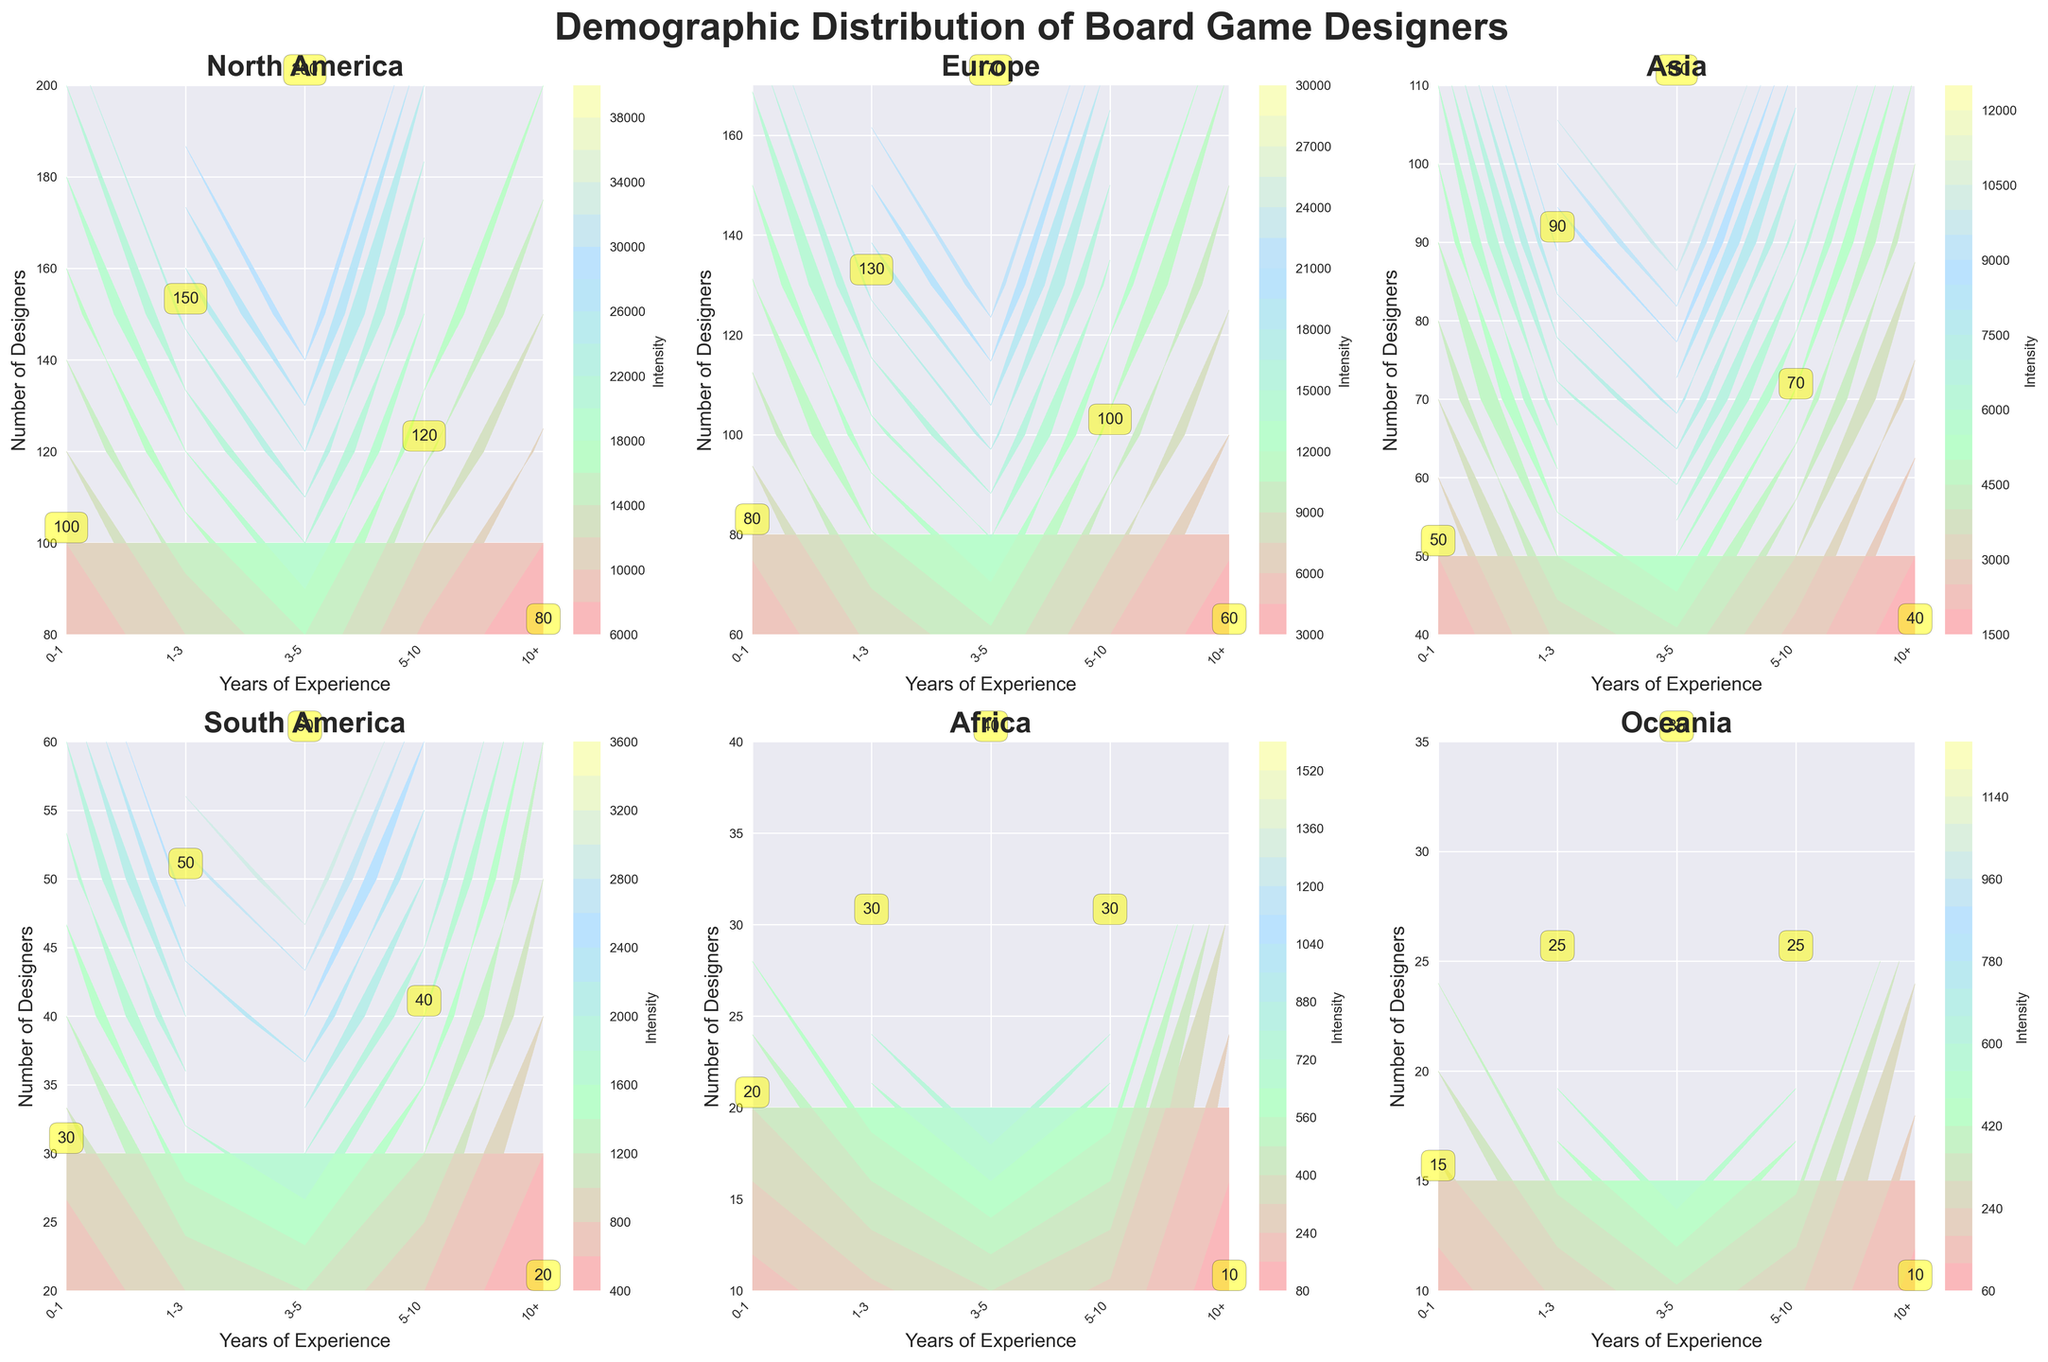What is the title of the figure? The title is displayed at the top of the figure in bold and large font. It summarizes the main focus of the plot.
Answer: Demographic Distribution of Board Game Designers How many regions are presented in the figure? Each region has its own subplot, and the regions are labeled at the top of each subplot. By counting the number of subplots, you can determine the number of regions.
Answer: 6 Which region has the most board game designers with 3-5 years of experience? Refer to the subplots labeled by region and look for the contour plot with the highest value corresponding to the 3-5 years of experience on the x-axis.
Answer: North America Which region shows the least number of designers with over 10 years of experience? Look at the values annotated in the subplots corresponding to the "10+" years of experience for all regions, and identify the smallest value.
Answer: Africa Which region and experience level combination has the highest intensity on the contour plot? Intensity can be gauged by the color gradient in the contour plot. Identify the region and experience level where the color is most intense (darker or most prominent color).
Answer: North America, 3-5 years Compare the number of designers with 0-1 years of experience in Europe and Asia. Which region has more? Find the subplots for Europe and Asia, then compare the annotated numbers of designers with 0-1 years of experience from both regions.
Answer: Europe How does the number of designers with 5-10 years of experience in South America compare to Oceania? Locate the subplots for South America and Oceania, then compare the annotated numbers of designers with 5-10 years of experience.
Answer: South America has more What is the average number of designers with 1-3 years of experience across all regions? Sum the number of designers with 1-3 years of experience from each region and divide by the number of regions (6).
Answer: (150 + 130 + 90 + 50 + 30 + 25) / 6 = 475 / 6 ≈ 79 Identify the region with the most significant drop in the number of designers from the 3-5 years category to the 10+ years category. Look for the region showing the largest decrease by subtracting the number of designers in the 10+ years category from the 3-5 years category for each region.
Answer: North America (200 - 80 = 120) 